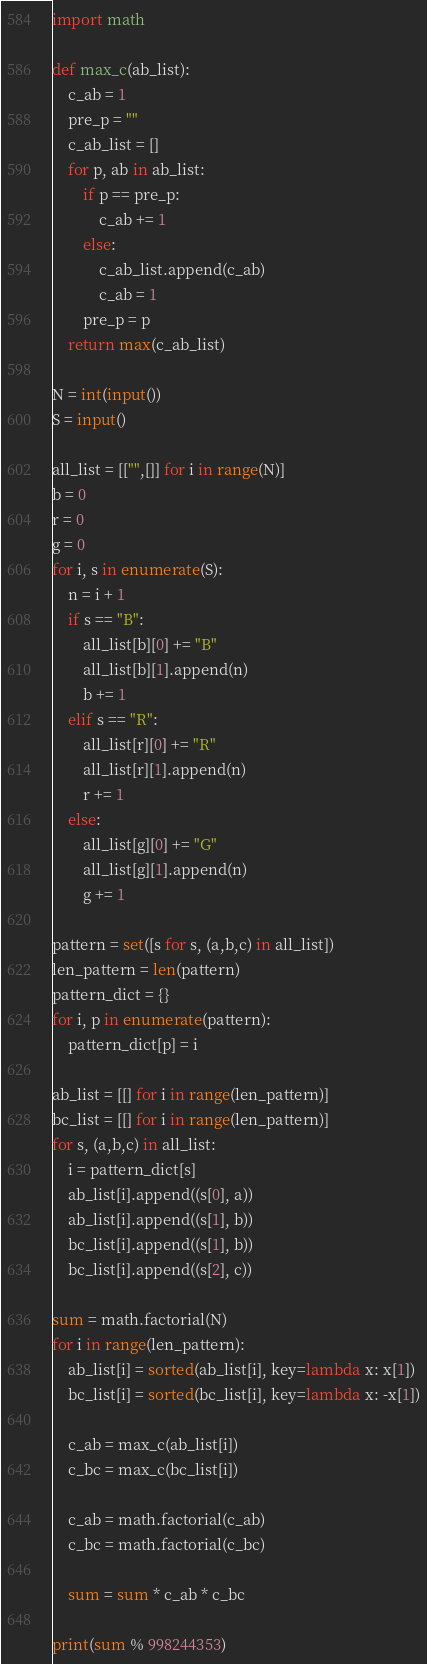<code> <loc_0><loc_0><loc_500><loc_500><_Python_>import math

def max_c(ab_list):
    c_ab = 1
    pre_p = ""
    c_ab_list = []
    for p, ab in ab_list:
        if p == pre_p:
            c_ab += 1
        else:
            c_ab_list.append(c_ab)
            c_ab = 1
        pre_p = p
    return max(c_ab_list)

N = int(input())
S = input()

all_list = [["",[]] for i in range(N)]
b = 0
r = 0
g = 0
for i, s in enumerate(S):
    n = i + 1
    if s == "B":
        all_list[b][0] += "B"
        all_list[b][1].append(n)
        b += 1
    elif s == "R":
        all_list[r][0] += "R"
        all_list[r][1].append(n)
        r += 1
    else:
        all_list[g][0] += "G"
        all_list[g][1].append(n)
        g += 1

pattern = set([s for s, (a,b,c) in all_list])
len_pattern = len(pattern)
pattern_dict = {}
for i, p in enumerate(pattern):
    pattern_dict[p] = i

ab_list = [[] for i in range(len_pattern)]
bc_list = [[] for i in range(len_pattern)]
for s, (a,b,c) in all_list:
    i = pattern_dict[s]
    ab_list[i].append((s[0], a))
    ab_list[i].append((s[1], b))
    bc_list[i].append((s[1], b))
    bc_list[i].append((s[2], c))

sum = math.factorial(N) 
for i in range(len_pattern):
    ab_list[i] = sorted(ab_list[i], key=lambda x: x[1])
    bc_list[i] = sorted(bc_list[i], key=lambda x: -x[1])
    
    c_ab = max_c(ab_list[i])
    c_bc = max_c(bc_list[i])
    
    c_ab = math.factorial(c_ab)
    c_bc = math.factorial(c_bc)

    sum = sum * c_ab * c_bc

print(sum % 998244353)</code> 